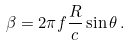Convert formula to latex. <formula><loc_0><loc_0><loc_500><loc_500>\beta = 2 \pi f \frac { R } { c } \sin \theta \, .</formula> 